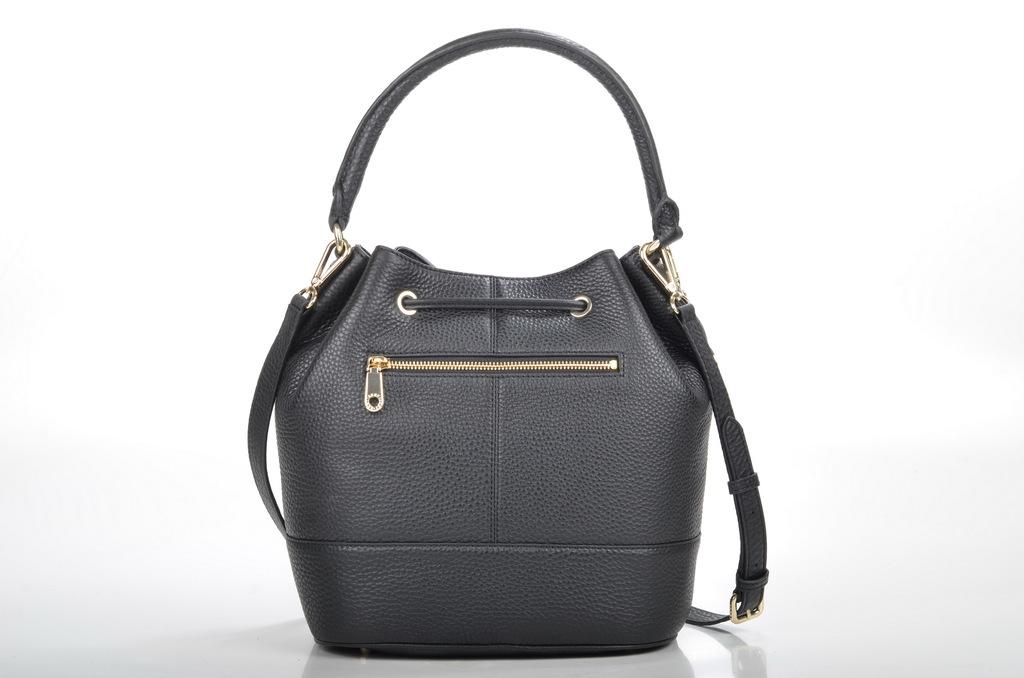What object is present in the image that can be used for carrying items? There is a bag in the image that can be used for carrying items. How can the contents of the bag be secured? The bag has a zip that can be used to secure the contents. Is there any additional feature attached to the bag? Yes, there is a belt attached to the bag. Can you see any deer interacting with the bag in the image? No, there are no deer present in the image. How many beads are attached to the belt of the bag in the image? There are no beads attached to the belt of the bag in the image. 